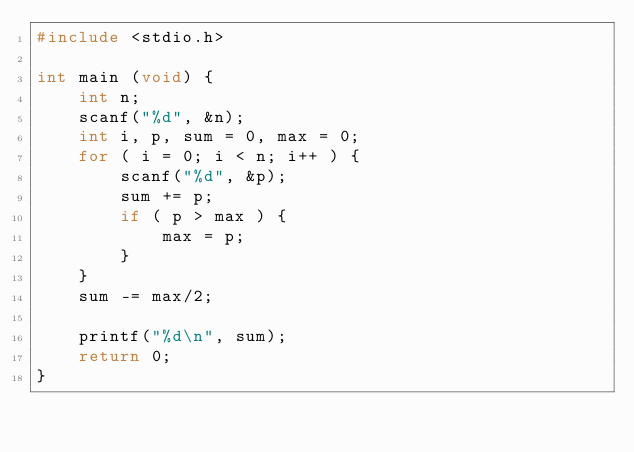<code> <loc_0><loc_0><loc_500><loc_500><_C_>#include <stdio.h>

int main (void) {
    int n;
    scanf("%d", &n);
    int i, p, sum = 0, max = 0;
    for ( i = 0; i < n; i++ ) {
        scanf("%d", &p);
        sum += p;
        if ( p > max ) {
            max = p;
        }
    }
    sum -= max/2;

    printf("%d\n", sum);
    return 0;
}</code> 